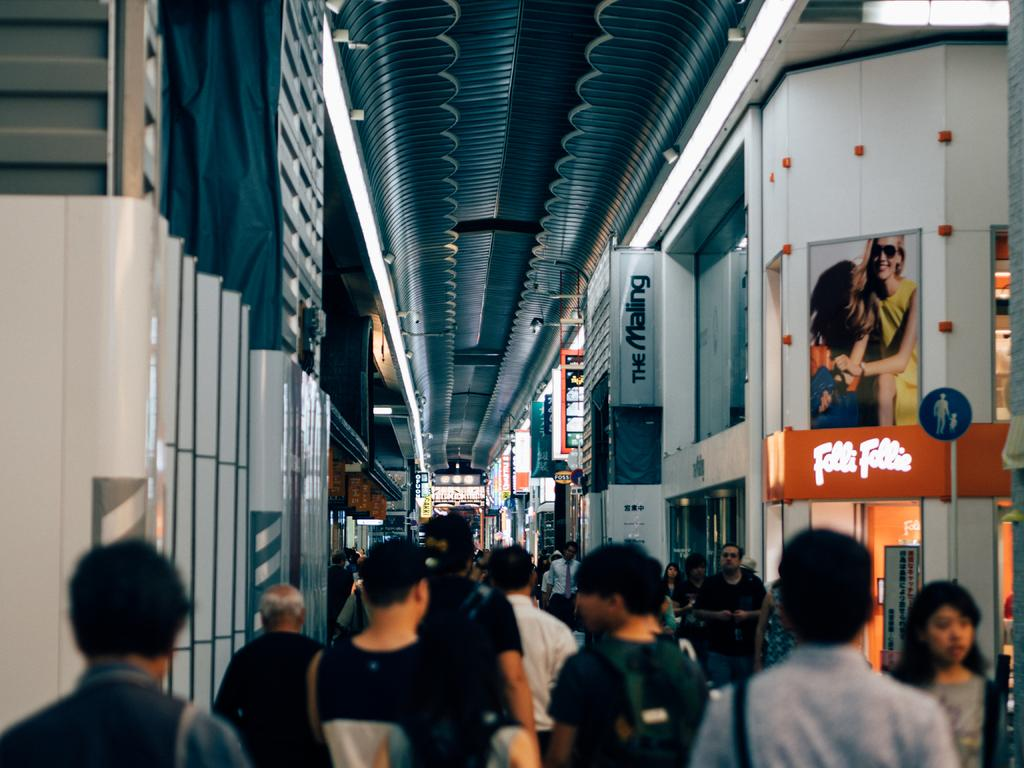How many people are in the image? There is a group of persons in the image. Where are the persons located in the image? The persons are standing at the bottom of the image. What can be seen in the background of the image? There is a wall in the background of the image. What type of worm can be seen providing comfort to the persons in the image? There is no worm present in the image, and therefore no such interaction can be observed. 